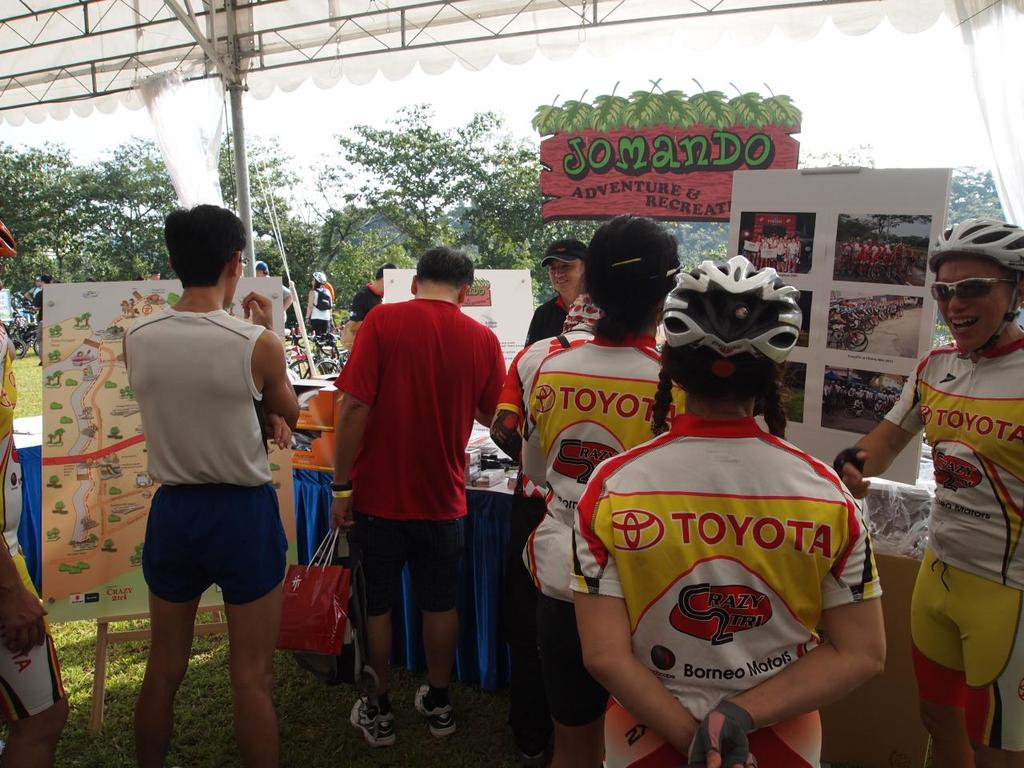What event is being depicted in the image, and what activities are associated with it? This image likely depicts a recreational or sporting event focused on cycling, as seen from the gear and attire of the participants. The presence of an event map and a booth marked 'Somando Adventure & Recreation' suggests activities may include guided bike tours or races in a scenic or challenge-driven environment. 